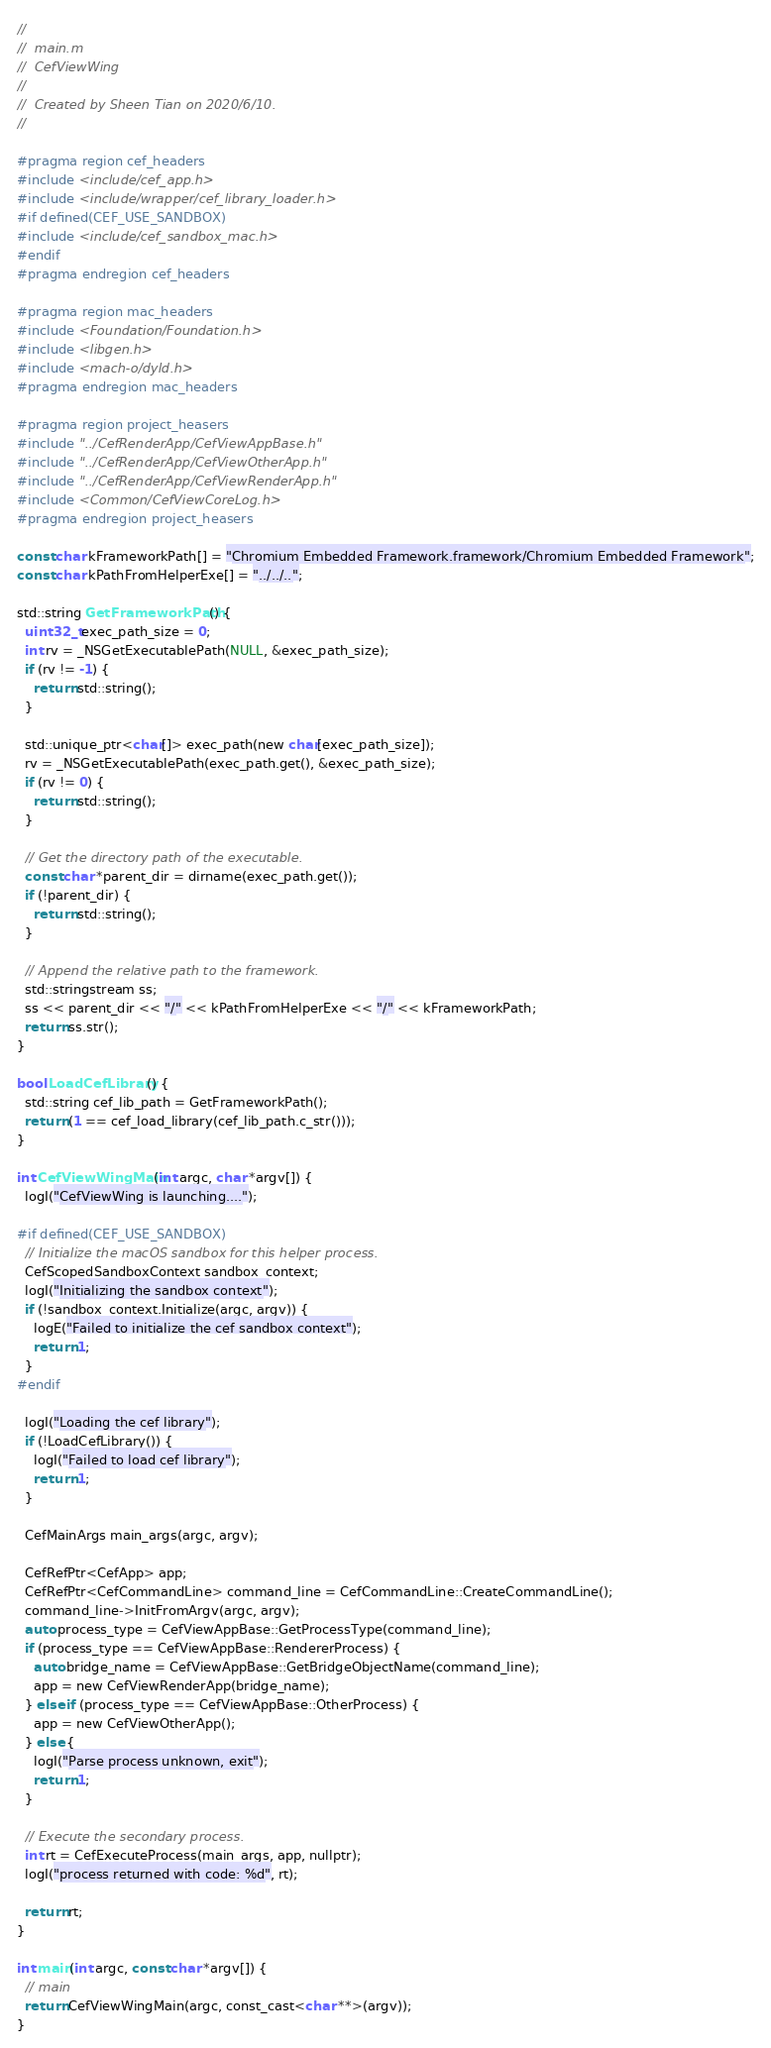<code> <loc_0><loc_0><loc_500><loc_500><_ObjectiveC_>//
//  main.m
//  CefViewWing
//
//  Created by Sheen Tian on 2020/6/10.
//

#pragma region cef_headers
#include <include/cef_app.h>
#include <include/wrapper/cef_library_loader.h>
#if defined(CEF_USE_SANDBOX)
#include <include/cef_sandbox_mac.h>
#endif
#pragma endregion cef_headers

#pragma region mac_headers
#include <Foundation/Foundation.h>
#include <libgen.h>
#include <mach-o/dyld.h>
#pragma endregion mac_headers

#pragma region project_heasers
#include "../CefRenderApp/CefViewAppBase.h"
#include "../CefRenderApp/CefViewOtherApp.h"
#include "../CefRenderApp/CefViewRenderApp.h"
#include <Common/CefViewCoreLog.h>
#pragma endregion project_heasers

const char kFrameworkPath[] = "Chromium Embedded Framework.framework/Chromium Embedded Framework";
const char kPathFromHelperExe[] = "../../..";

std::string GetFrameworkPath() {
  uint32_t exec_path_size = 0;
  int rv = _NSGetExecutablePath(NULL, &exec_path_size);
  if (rv != -1) {
    return std::string();
  }

  std::unique_ptr<char[]> exec_path(new char[exec_path_size]);
  rv = _NSGetExecutablePath(exec_path.get(), &exec_path_size);
  if (rv != 0) {
    return std::string();
  }

  // Get the directory path of the executable.
  const char *parent_dir = dirname(exec_path.get());
  if (!parent_dir) {
    return std::string();
  }

  // Append the relative path to the framework.
  std::stringstream ss;
  ss << parent_dir << "/" << kPathFromHelperExe << "/" << kFrameworkPath;
  return ss.str();
}

bool LoadCefLibrary() {
  std::string cef_lib_path = GetFrameworkPath();
  return (1 == cef_load_library(cef_lib_path.c_str()));
}

int CefViewWingMain(int argc, char *argv[]) {
  logI("CefViewWing is launching....");

#if defined(CEF_USE_SANDBOX)
  // Initialize the macOS sandbox for this helper process.
  CefScopedSandboxContext sandbox_context;
  logI("Initializing the sandbox context");
  if (!sandbox_context.Initialize(argc, argv)) {
    logE("Failed to initialize the cef sandbox context");
    return 1;
  }
#endif

  logI("Loading the cef library");
  if (!LoadCefLibrary()) {
    logI("Failed to load cef library");
    return 1;
  }

  CefMainArgs main_args(argc, argv);

  CefRefPtr<CefApp> app;
  CefRefPtr<CefCommandLine> command_line = CefCommandLine::CreateCommandLine();
  command_line->InitFromArgv(argc, argv);
  auto process_type = CefViewAppBase::GetProcessType(command_line);
  if (process_type == CefViewAppBase::RendererProcess) {
    auto bridge_name = CefViewAppBase::GetBridgeObjectName(command_line);
    app = new CefViewRenderApp(bridge_name);
  } else if (process_type == CefViewAppBase::OtherProcess) {
    app = new CefViewOtherApp();
  } else {
    logI("Parse process unknown, exit");
    return 1;
  }

  // Execute the secondary process.
  int rt = CefExecuteProcess(main_args, app, nullptr);
  logI("process returned with code: %d", rt);

  return rt;
}

int main(int argc, const char *argv[]) {
  // main
  return CefViewWingMain(argc, const_cast<char **>(argv));
}
</code> 